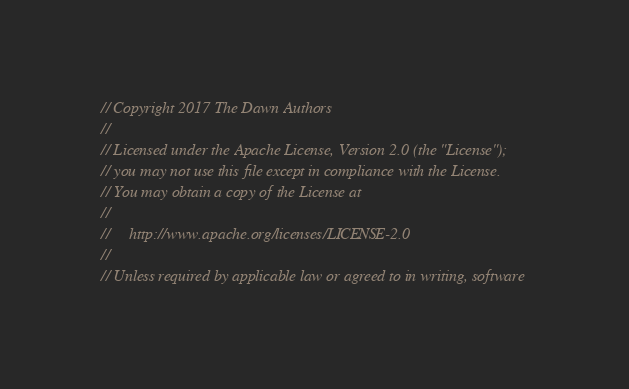<code> <loc_0><loc_0><loc_500><loc_500><_ObjectiveC_>// Copyright 2017 The Dawn Authors
//
// Licensed under the Apache License, Version 2.0 (the "License");
// you may not use this file except in compliance with the License.
// You may obtain a copy of the License at
//
//     http://www.apache.org/licenses/LICENSE-2.0
//
// Unless required by applicable law or agreed to in writing, software</code> 